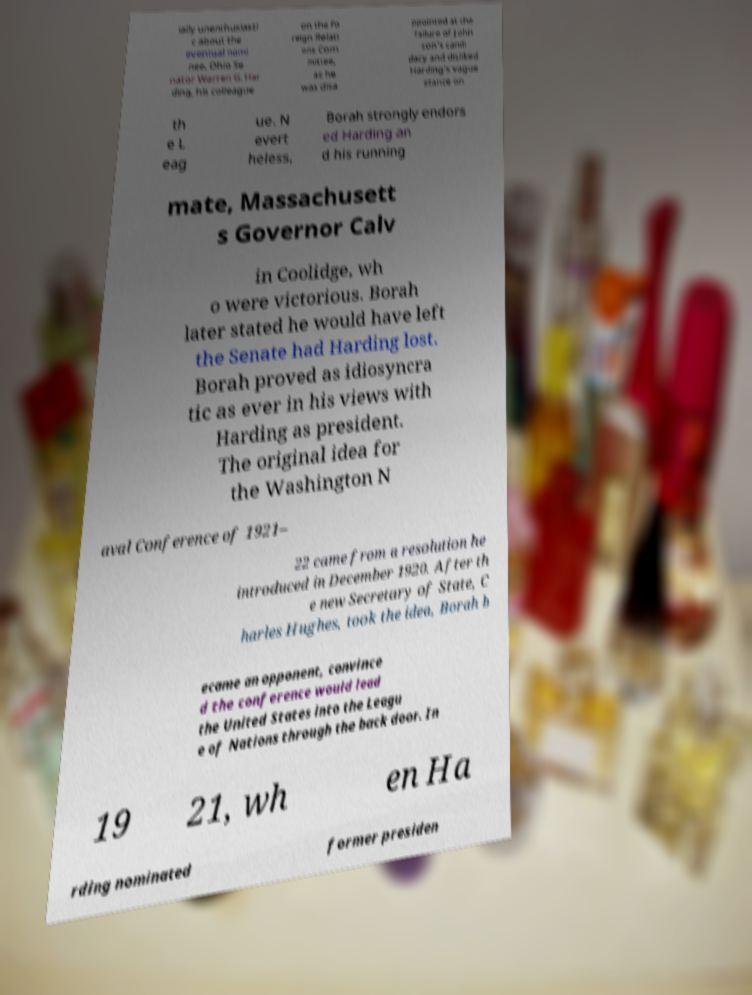What messages or text are displayed in this image? I need them in a readable, typed format. ially unenthusiasti c about the eventual nomi nee, Ohio Se nator Warren G. Har ding, his colleague on the Fo reign Relati ons Com mittee, as he was disa ppointed at the failure of John son's candi dacy and disliked Harding's vague stance on th e L eag ue. N evert heless, Borah strongly endors ed Harding an d his running mate, Massachusett s Governor Calv in Coolidge, wh o were victorious. Borah later stated he would have left the Senate had Harding lost. Borah proved as idiosyncra tic as ever in his views with Harding as president. The original idea for the Washington N aval Conference of 1921– 22 came from a resolution he introduced in December 1920. After th e new Secretary of State, C harles Hughes, took the idea, Borah b ecame an opponent, convince d the conference would lead the United States into the Leagu e of Nations through the back door. In 19 21, wh en Ha rding nominated former presiden 